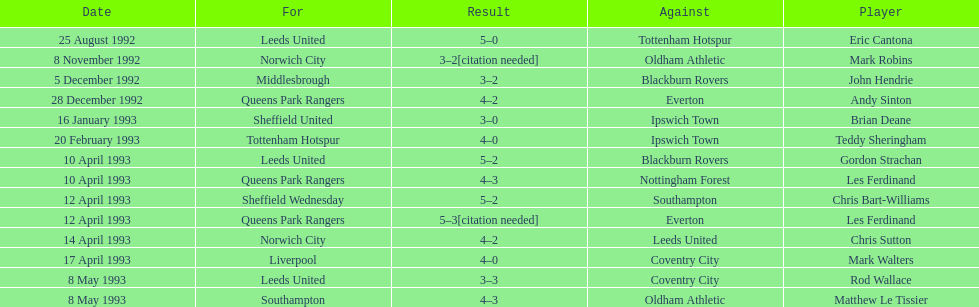Southampton played on may 8th, 1993, who was their opponent? Oldham Athletic. 